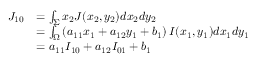<formula> <loc_0><loc_0><loc_500><loc_500>\begin{array} { r l } { { J _ { 1 0 } } } & { = \int _ { \Sigma } { { x _ { 2 } } J ( { x _ { 2 } } , { y _ { 2 } } ) d { x _ { 2 } } d { y _ { 2 } } } } \\ & { = \int _ { \Omega } { \left ( { { a _ { 1 1 } } { x _ { 1 } } + { a _ { 1 2 } } { y _ { 1 } } + { b _ { 1 } } } \right ) I ( { x _ { 1 } } , { y _ { 1 } } ) d { x _ { 1 } } d { y _ { 1 } } } } \\ & { = { a _ { 1 1 } } { I _ { 1 0 } } + { a _ { 1 2 } } { I _ { 0 1 } } + { b _ { 1 } } } \end{array}</formula> 